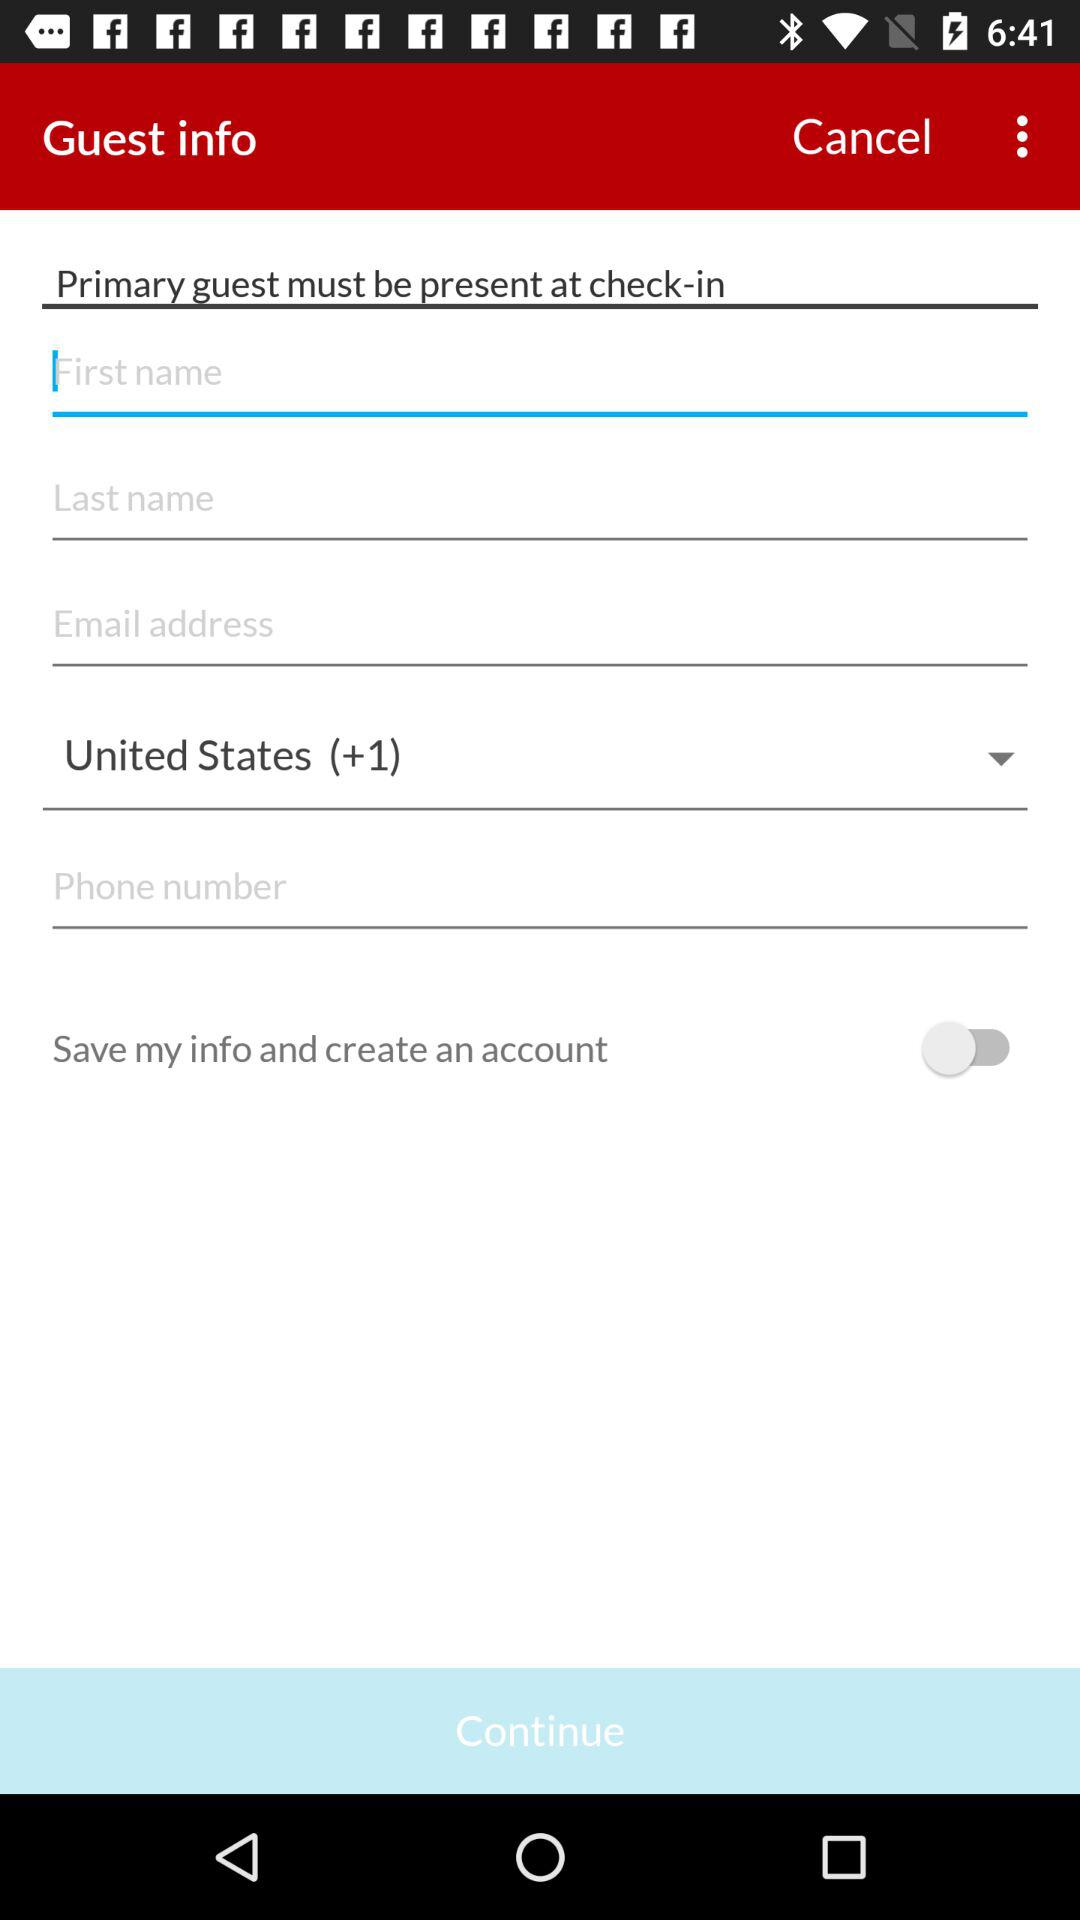What is the status of "Save my info and create an account"? The status is "off". 